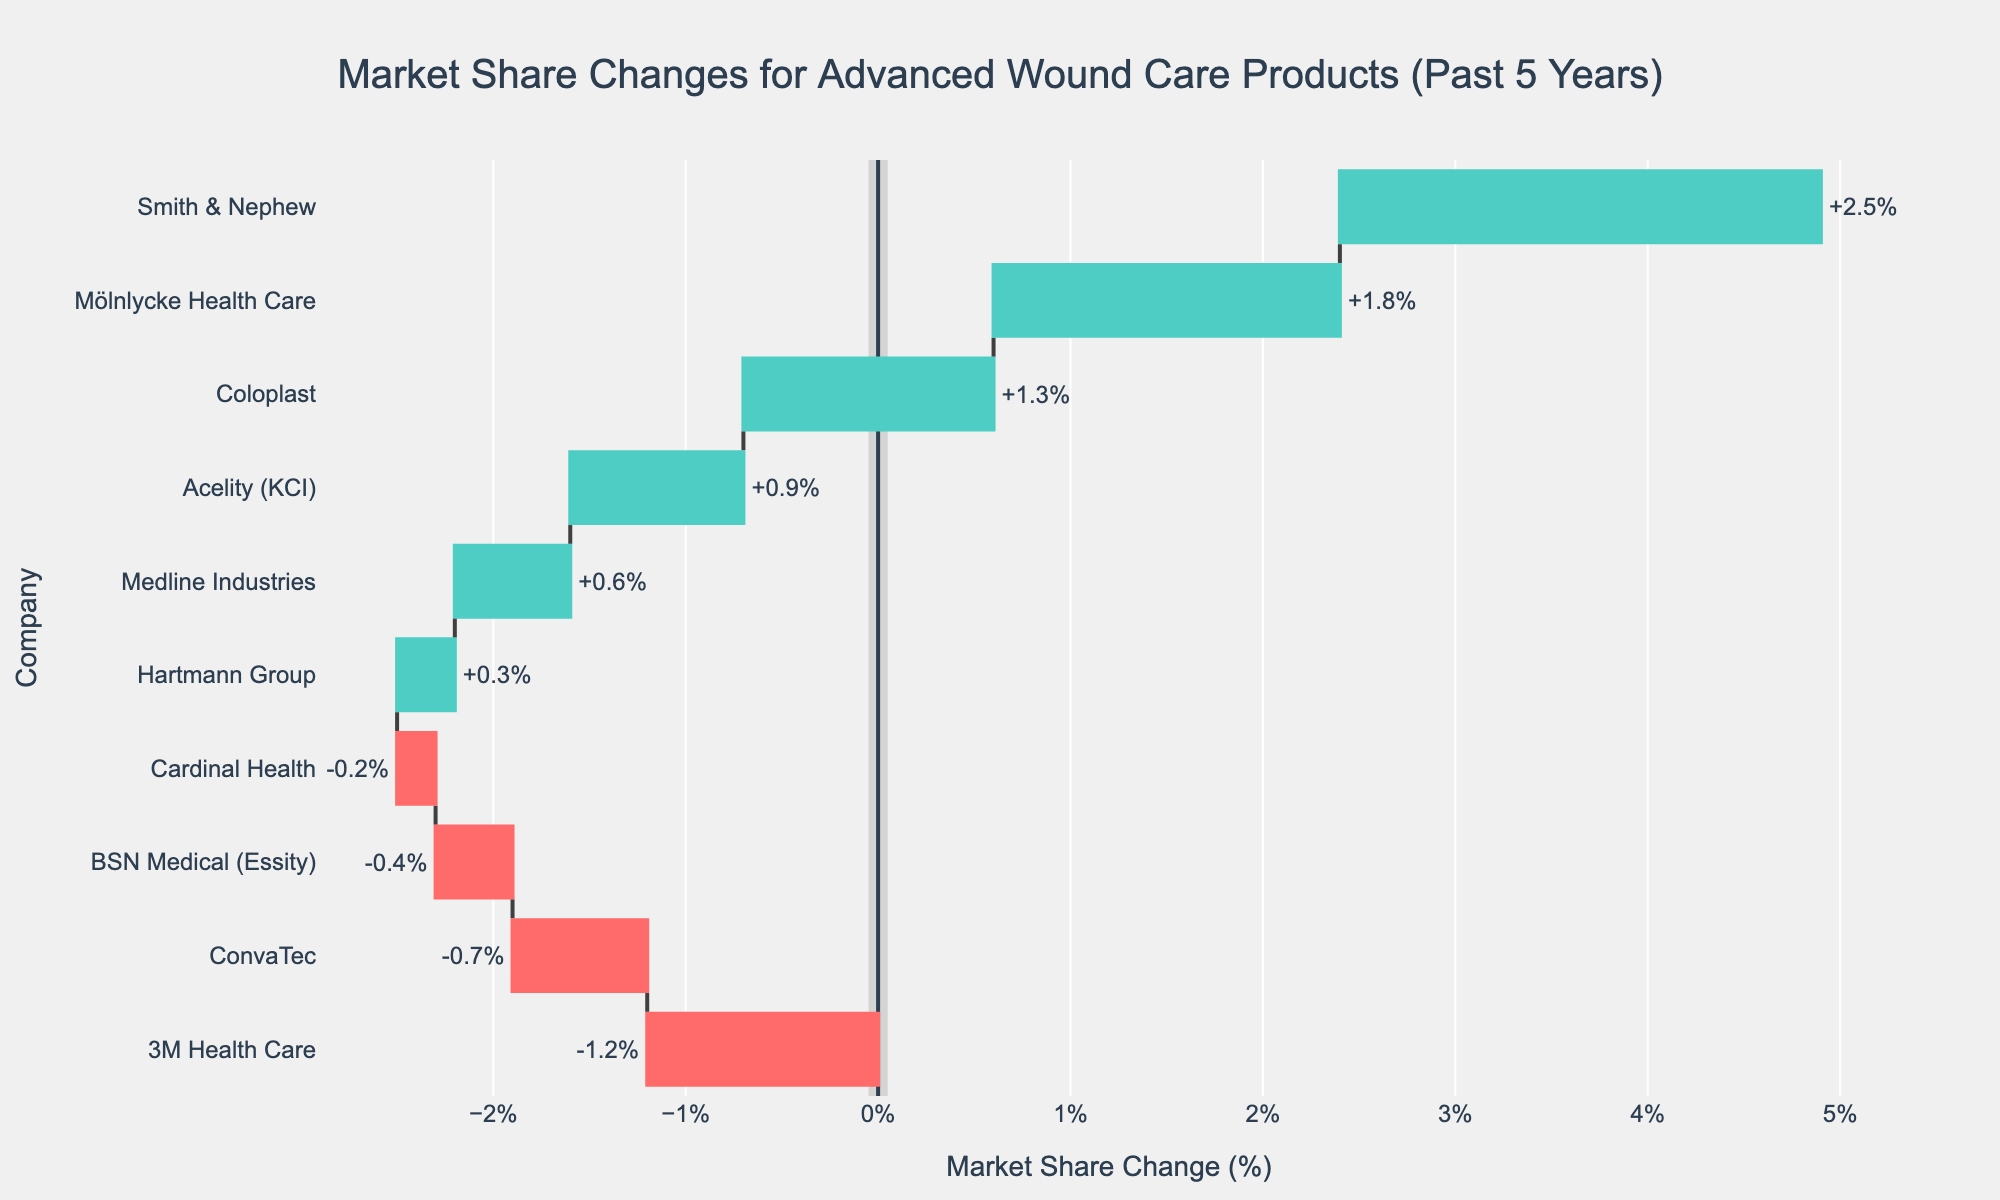What is the title of the figure? The title of the figure is usually located at the top and provides a summary of what the chart represents. Look at the top of the chart where the largest text is located.
Answer: Market Share Changes for Advanced Wound Care Products (Past 5 Years) How many companies experienced a decrease in market share? To find this, look at the color coding of the bars in the waterfall chart. The bars colored red indicate a decrease in market share. Count these red bars.
Answer: 4 Which company had the largest increase in market share? Look at the height of the green bars. The tallest green bar represents the largest percentage increase.
Answer: Smith & Nephew What is the change in market share for ConvaTec? Find the bar labeled "ConvaTec" and read the value associated with it.
Answer: -0.7% What's the combined market share change for companies with a positive change? Sum the percentages of all companies that have a green bar (positive market share change). Smith & Nephew (+2.5), Mölnlycke Health Care (+1.8), Coloplast (+1.3), Acelity (KCI) (+0.9), Medline Industries (+0.6), Hartmann Group (+0.3). Total = 2.5 + 1.8 + 1.3 + 0.9 + 0.6 + 0.3 = 7.4
Answer: +7.4% Compare the market share changes of 3M Health Care and Mölnlycke Health Care; which one saw a greater change? Identify the market share changes for both companies: 3M Health Care (-1.2) and Mölnlycke Health Care (+1.8). Compare the absolute values of these changes.
Answer: Mölnlycke Health Care What is the average market share change among all companies? Add the market share changes of all companies and then divide by the number of companies. Sum: 2.5 - 1.2 + 1.8 - 0.7 + 1.3 + 0.9 + 0.6 - 0.4 + 0.3 - 0.2 = 4.9. Number of companies: 10. Average = 4.9 / 10 = 0.49
Answer: +0.49% Which companies have an equal market share change? Check for companies that have the same length of bars and the same direction (either both positive or both negative).
Answer: No companies have an equal market share change What is the total market share change for companies with a negative change? Sum the percentages of all companies that have a red bar (negative market share change). 3M Health Care (-1.2), ConvaTec (-0.7), BSN Medical (Essity) (-0.4), Cardinal Health (-0.2). Total = -1.2 - 0.7 - 0.4 - 0.2 = -2.5
Answer: -2.5% Is the median of the market share changes positive or negative? First, list the market share changes in ascending order. The median is the middle value. Listed changes: -1.2, -0.7, -0.4, -0.2, 0.3, 0.6, 0.9, 1.3, 1.8, 2.5. Median value is the average of the 5th and 6th values (0.3, 0.6). Median = (0.3 + 0.6) / 2 = 0.45
Answer: Positive 